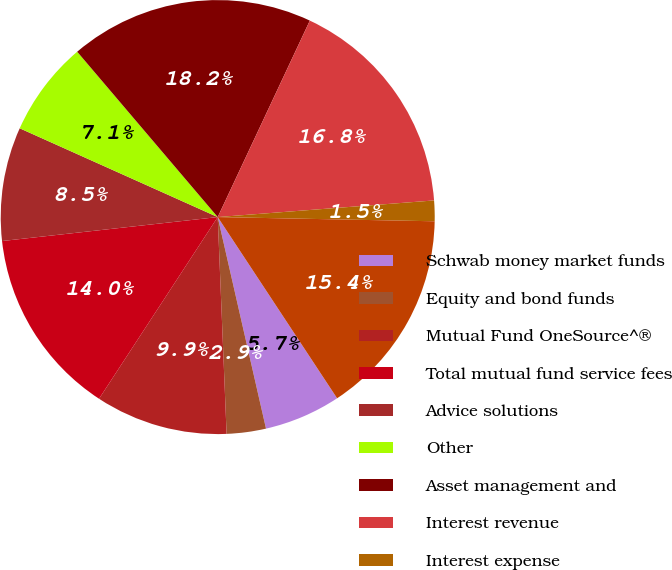<chart> <loc_0><loc_0><loc_500><loc_500><pie_chart><fcel>Schwab money market funds<fcel>Equity and bond funds<fcel>Mutual Fund OneSource^®<fcel>Total mutual fund service fees<fcel>Advice solutions<fcel>Other<fcel>Asset management and<fcel>Interest revenue<fcel>Interest expense<fcel>Net interest revenue<nl><fcel>5.7%<fcel>2.92%<fcel>9.86%<fcel>14.03%<fcel>8.47%<fcel>7.08%<fcel>18.19%<fcel>16.8%<fcel>1.53%<fcel>15.42%<nl></chart> 